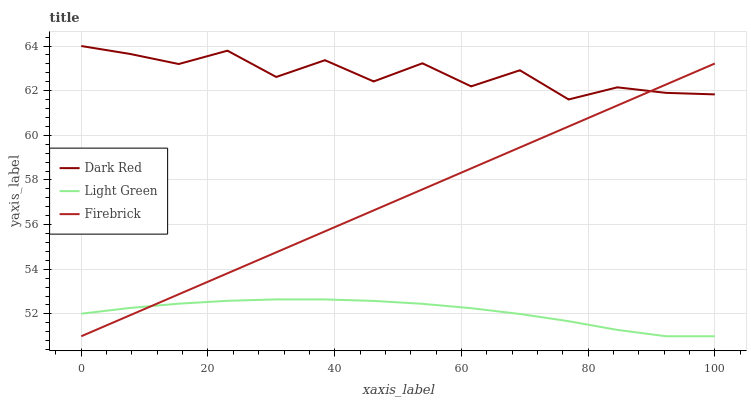Does Light Green have the minimum area under the curve?
Answer yes or no. Yes. Does Dark Red have the maximum area under the curve?
Answer yes or no. Yes. Does Firebrick have the minimum area under the curve?
Answer yes or no. No. Does Firebrick have the maximum area under the curve?
Answer yes or no. No. Is Firebrick the smoothest?
Answer yes or no. Yes. Is Dark Red the roughest?
Answer yes or no. Yes. Is Light Green the smoothest?
Answer yes or no. No. Is Light Green the roughest?
Answer yes or no. No. Does Firebrick have the lowest value?
Answer yes or no. Yes. Does Dark Red have the highest value?
Answer yes or no. Yes. Does Firebrick have the highest value?
Answer yes or no. No. Is Light Green less than Dark Red?
Answer yes or no. Yes. Is Dark Red greater than Light Green?
Answer yes or no. Yes. Does Firebrick intersect Light Green?
Answer yes or no. Yes. Is Firebrick less than Light Green?
Answer yes or no. No. Is Firebrick greater than Light Green?
Answer yes or no. No. Does Light Green intersect Dark Red?
Answer yes or no. No. 